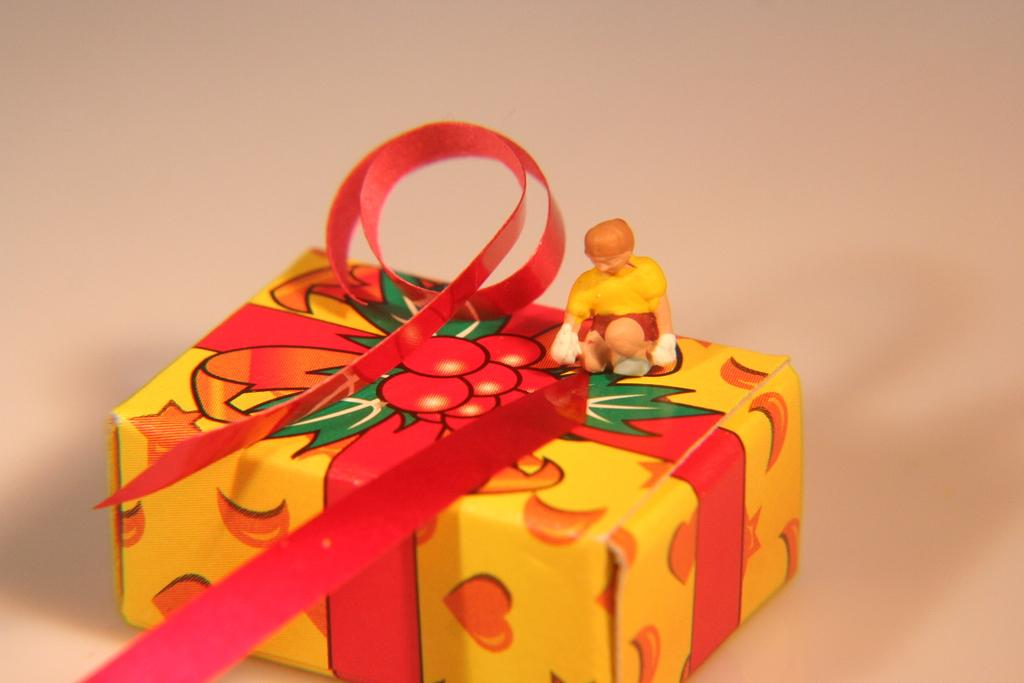What object in the image is designed for play or entertainment? There is a toy in the image. What other object in the image is related to gift-giving or celebration? There is a ribbon on a gift box in the image. What type of seed can be seen growing on the toy in the image? There is no seed present in the image, and the toy does not appear to be a plant or have any seeds. How many snails are crawling on the gift box in the image? There are no snails present in the image; the gift box only has a ribbon on it. 